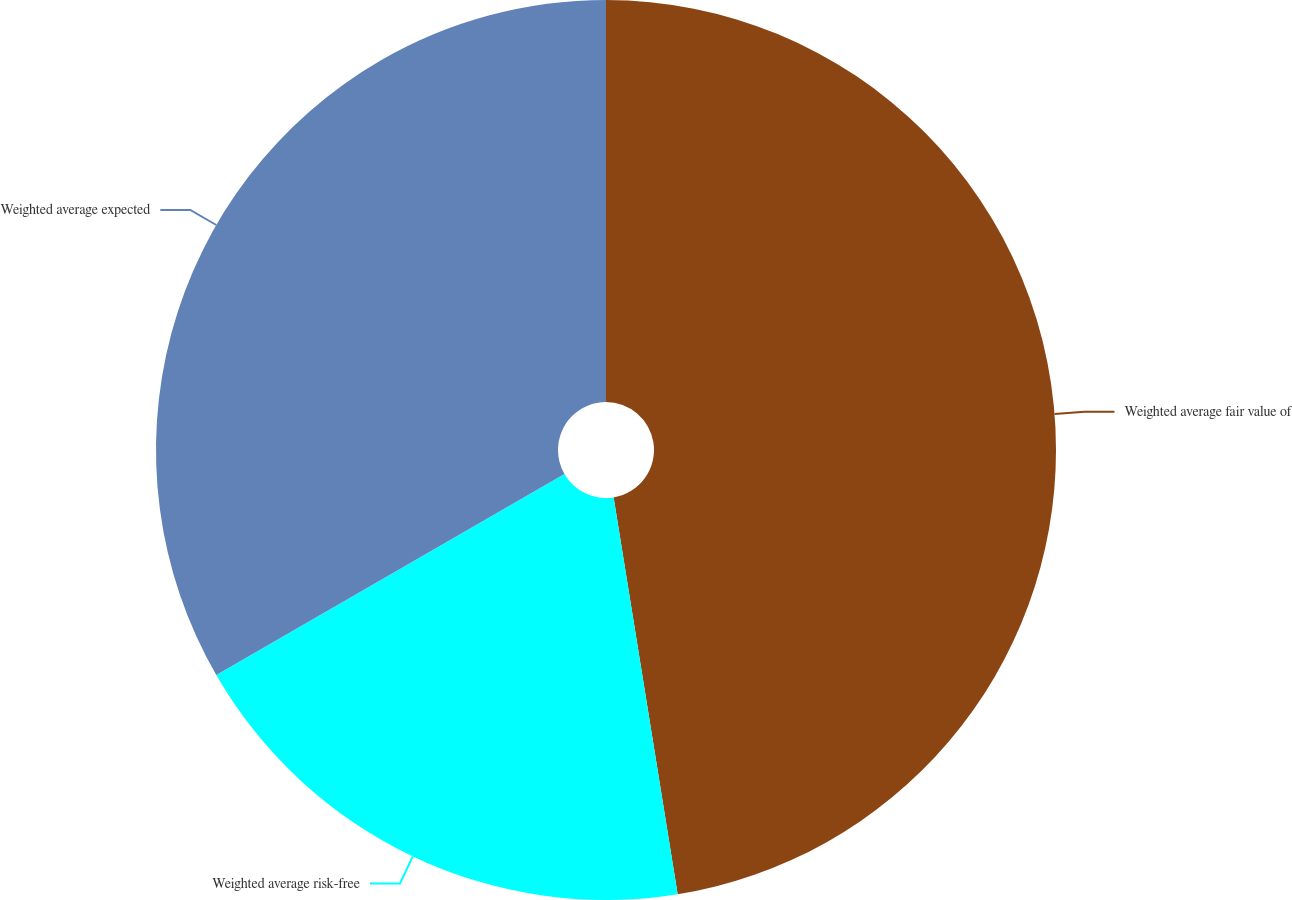Convert chart. <chart><loc_0><loc_0><loc_500><loc_500><pie_chart><fcel>Weighted average fair value of<fcel>Weighted average risk-free<fcel>Weighted average expected<nl><fcel>47.45%<fcel>19.21%<fcel>33.33%<nl></chart> 